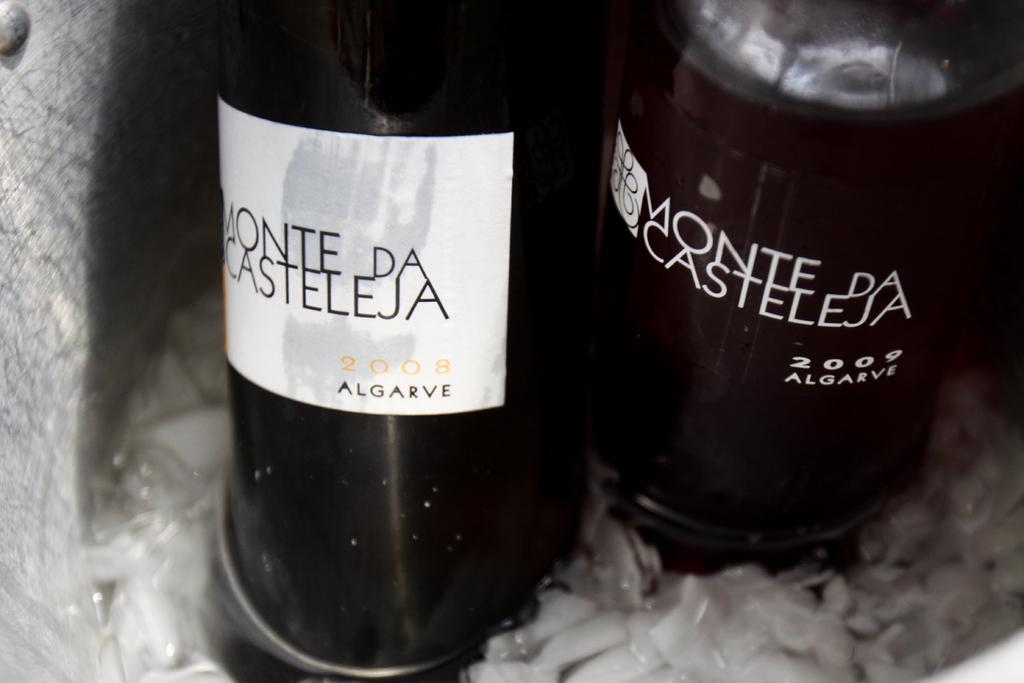What year is this wine?
Make the answer very short. 2009. What is the brand of wine?
Make the answer very short. Monte da casteleja. 